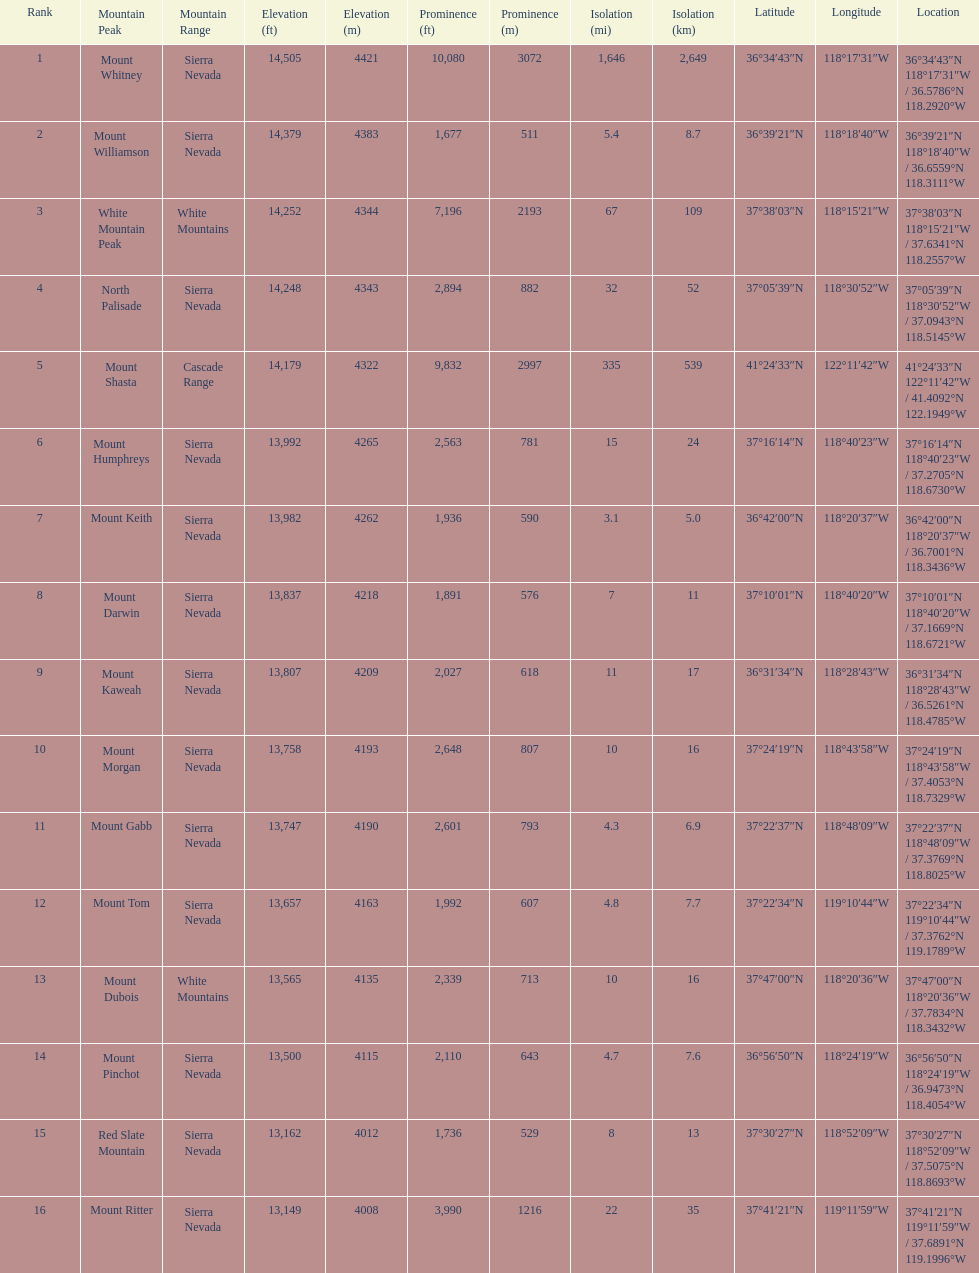Which mountain peak has a prominence more than 10,000 ft? Mount Whitney. 